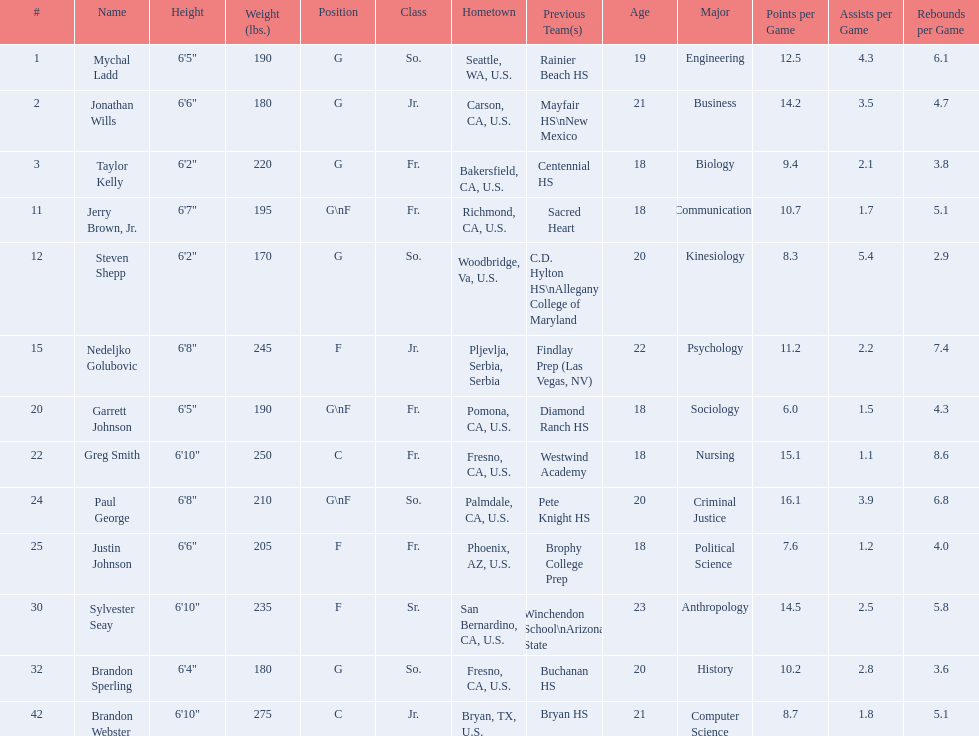What class was each team member in for the 2009-10 fresno state bulldogs? So., Jr., Fr., Fr., So., Jr., Fr., Fr., So., Fr., Sr., So., Jr. Which of these was outside of the us? Jr. Who was the player? Nedeljko Golubovic. 